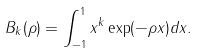<formula> <loc_0><loc_0><loc_500><loc_500>B _ { k } ( \rho ) = \int _ { - 1 } ^ { 1 } x ^ { k } \exp ( - \rho x ) d x .</formula> 